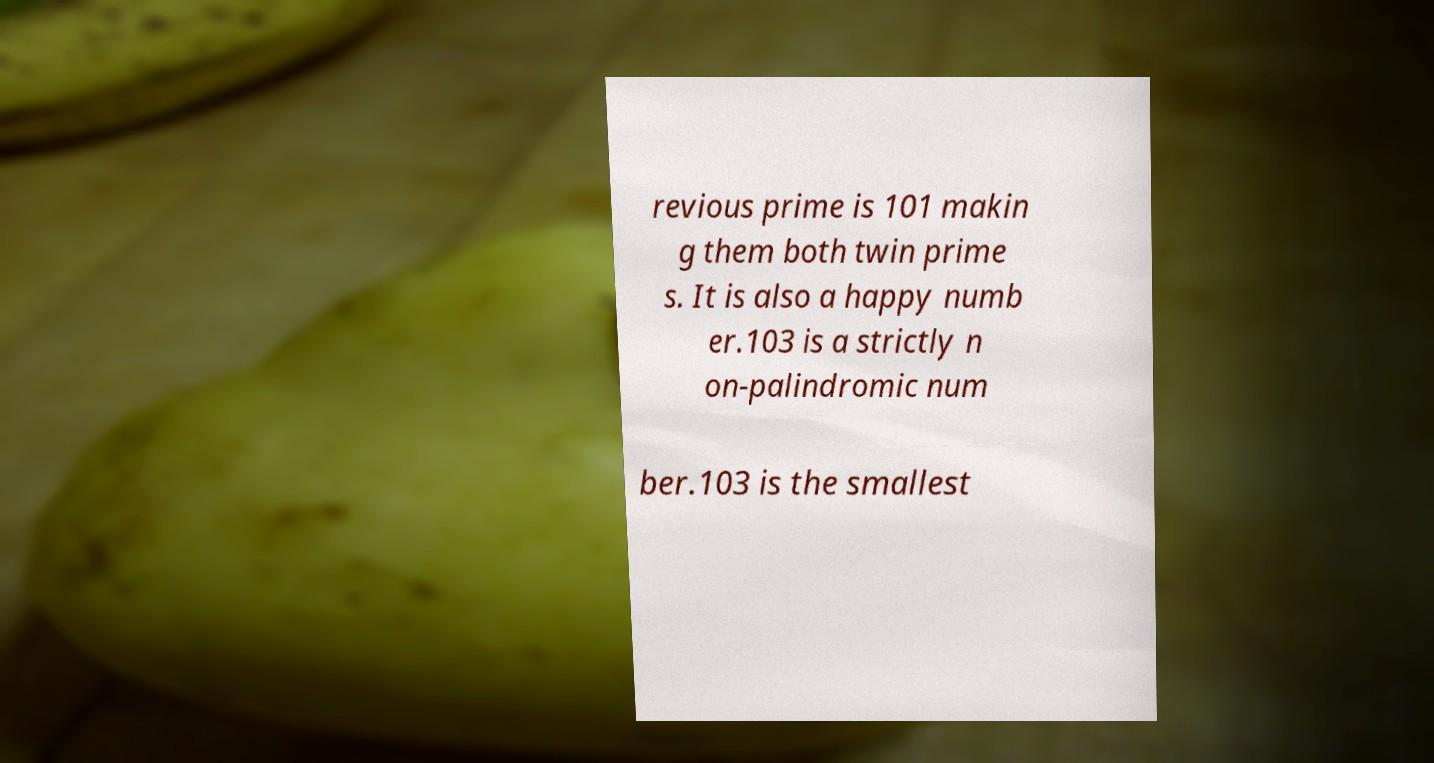I need the written content from this picture converted into text. Can you do that? revious prime is 101 makin g them both twin prime s. It is also a happy numb er.103 is a strictly n on-palindromic num ber.103 is the smallest 